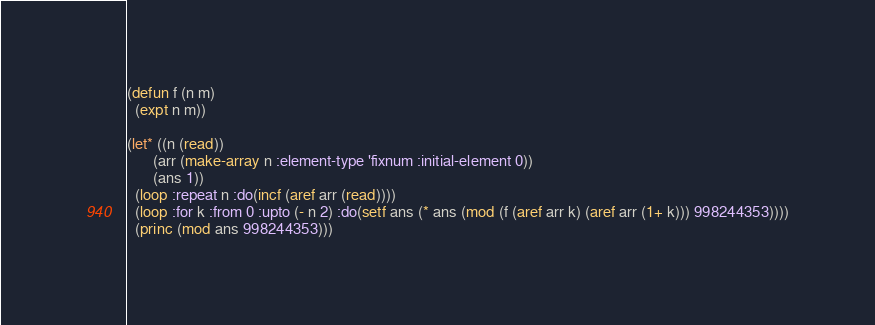<code> <loc_0><loc_0><loc_500><loc_500><_Lisp_>(defun f (n m)
  (expt n m))

(let* ((n (read))
       (arr (make-array n :element-type 'fixnum :initial-element 0))
       (ans 1))
  (loop :repeat n :do(incf (aref arr (read))))
  (loop :for k :from 0 :upto (- n 2) :do(setf ans (* ans (mod (f (aref arr k) (aref arr (1+ k))) 998244353))))
  (princ (mod ans 998244353)))
</code> 